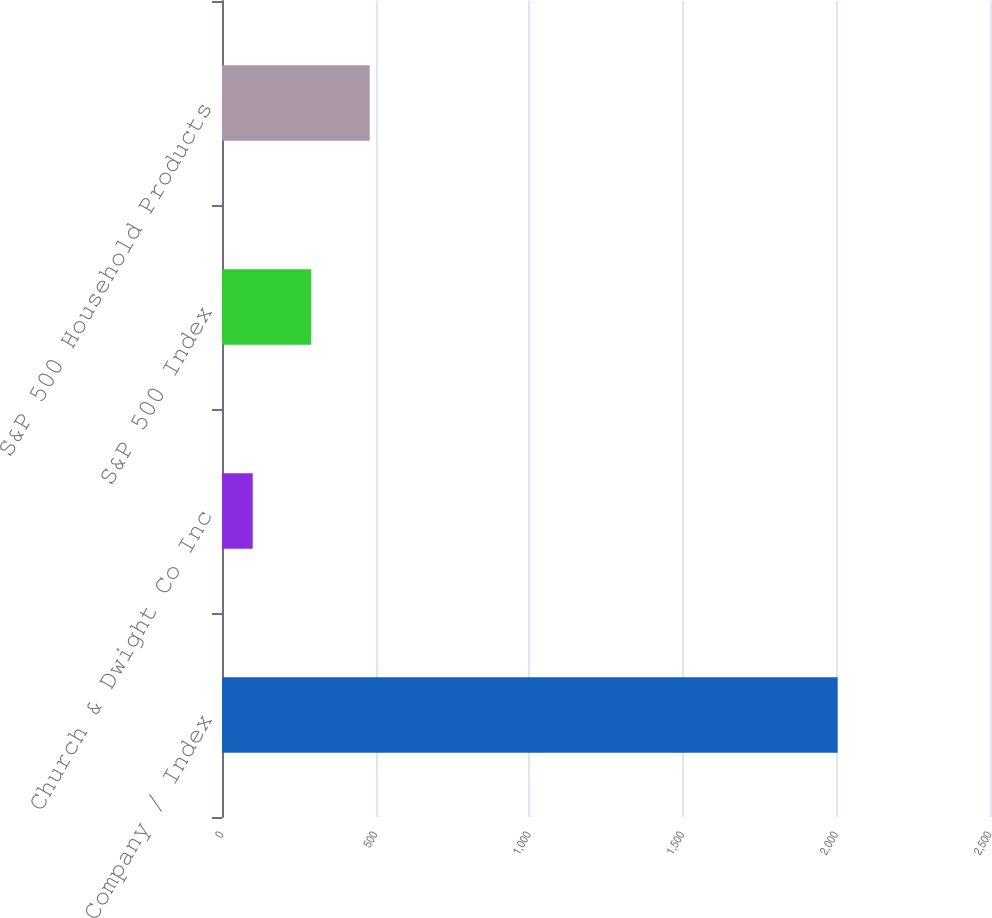<chart> <loc_0><loc_0><loc_500><loc_500><bar_chart><fcel>Company / Index<fcel>Church & Dwight Co Inc<fcel>S&P 500 Index<fcel>S&P 500 Household Products<nl><fcel>2004<fcel>100<fcel>290.4<fcel>480.8<nl></chart> 